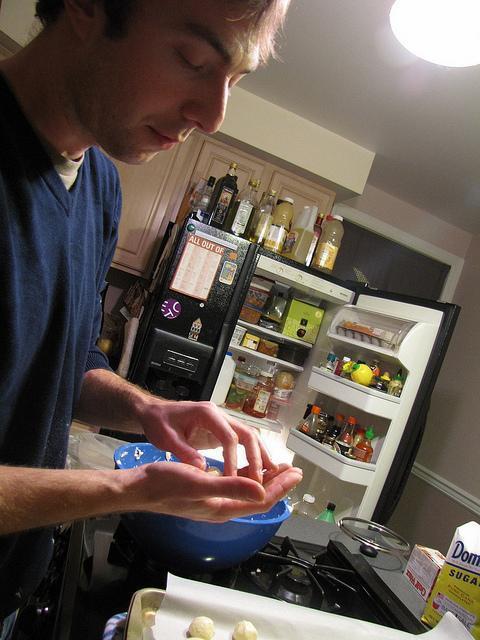What type of kitchen is shown?
Choose the correct response and explain in the format: 'Answer: answer
Rationale: rationale.'
Options: Commercial, hospital, food truck, residential. Answer: residential.
Rationale: Based on the refrigerator size and design and the setting in the background this would not be a professional kitchen and appears to be in a home setting. 